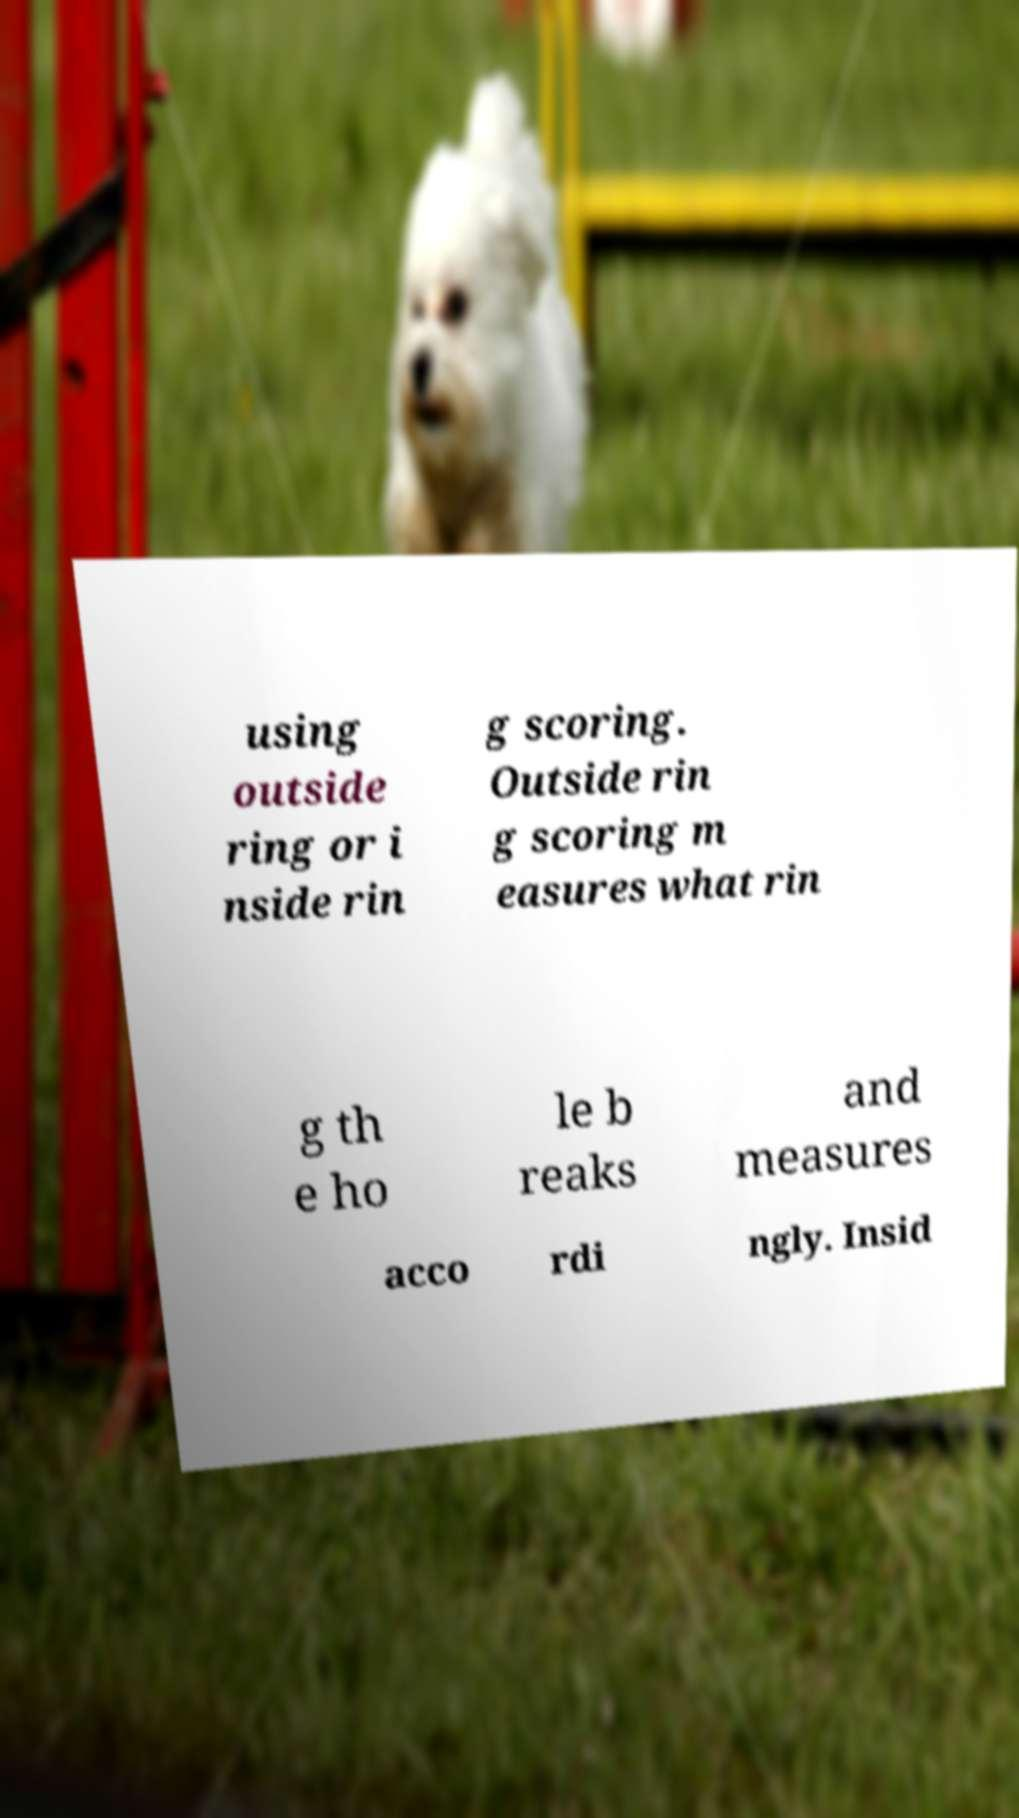Can you accurately transcribe the text from the provided image for me? using outside ring or i nside rin g scoring. Outside rin g scoring m easures what rin g th e ho le b reaks and measures acco rdi ngly. Insid 